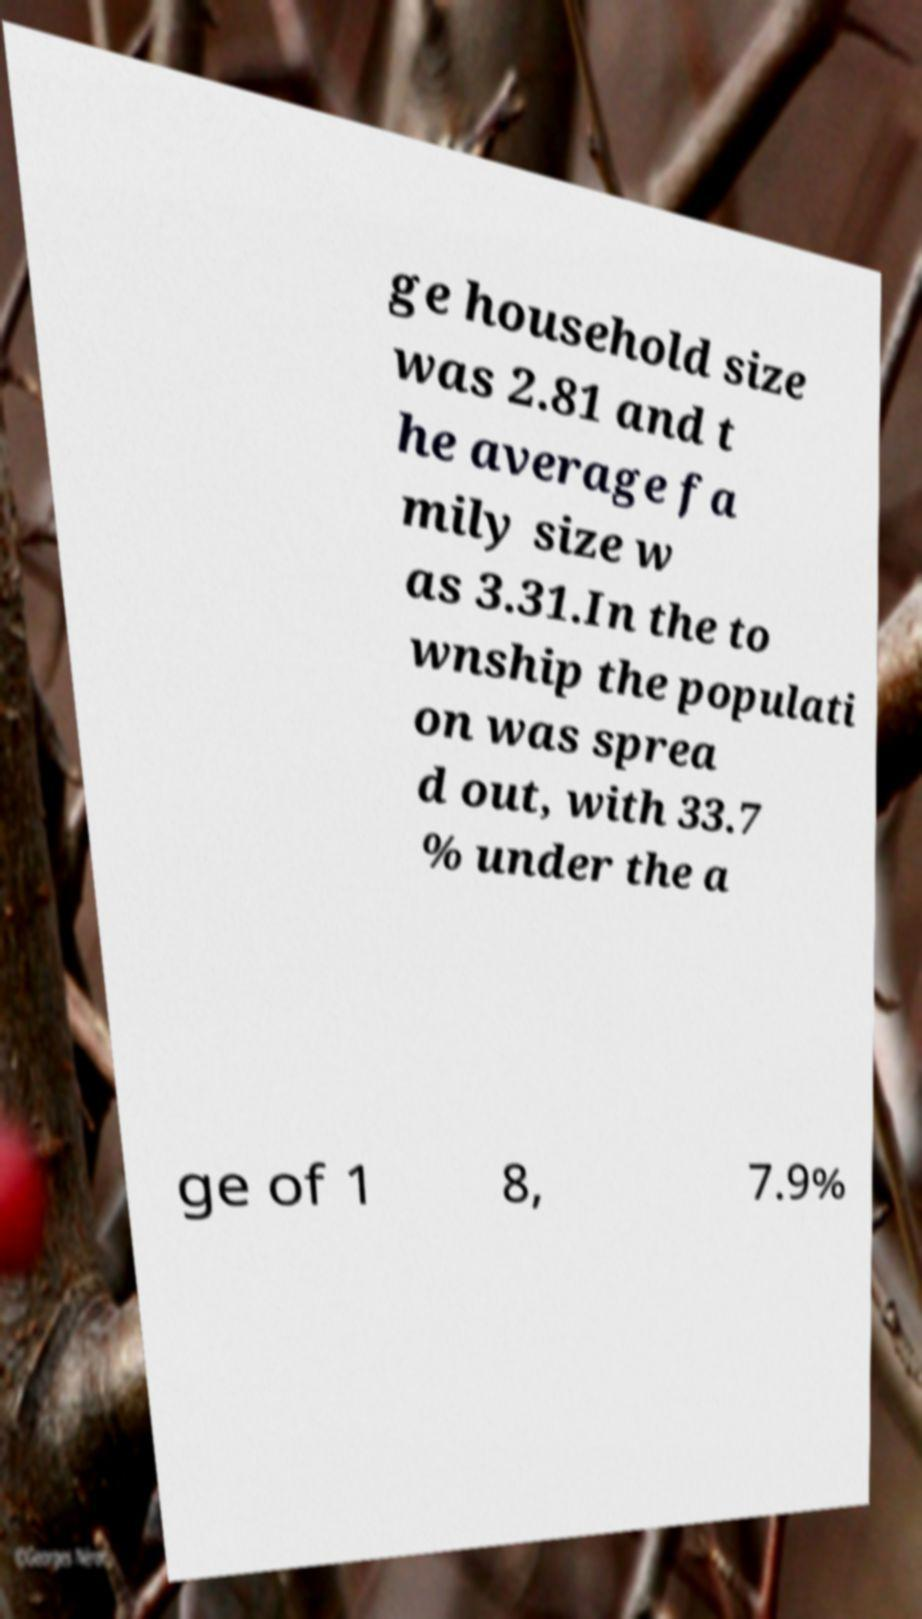Please read and relay the text visible in this image. What does it say? ge household size was 2.81 and t he average fa mily size w as 3.31.In the to wnship the populati on was sprea d out, with 33.7 % under the a ge of 1 8, 7.9% 